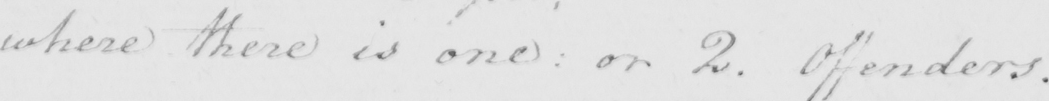Please provide the text content of this handwritten line. where there is one :  or 2 . Offenders . 